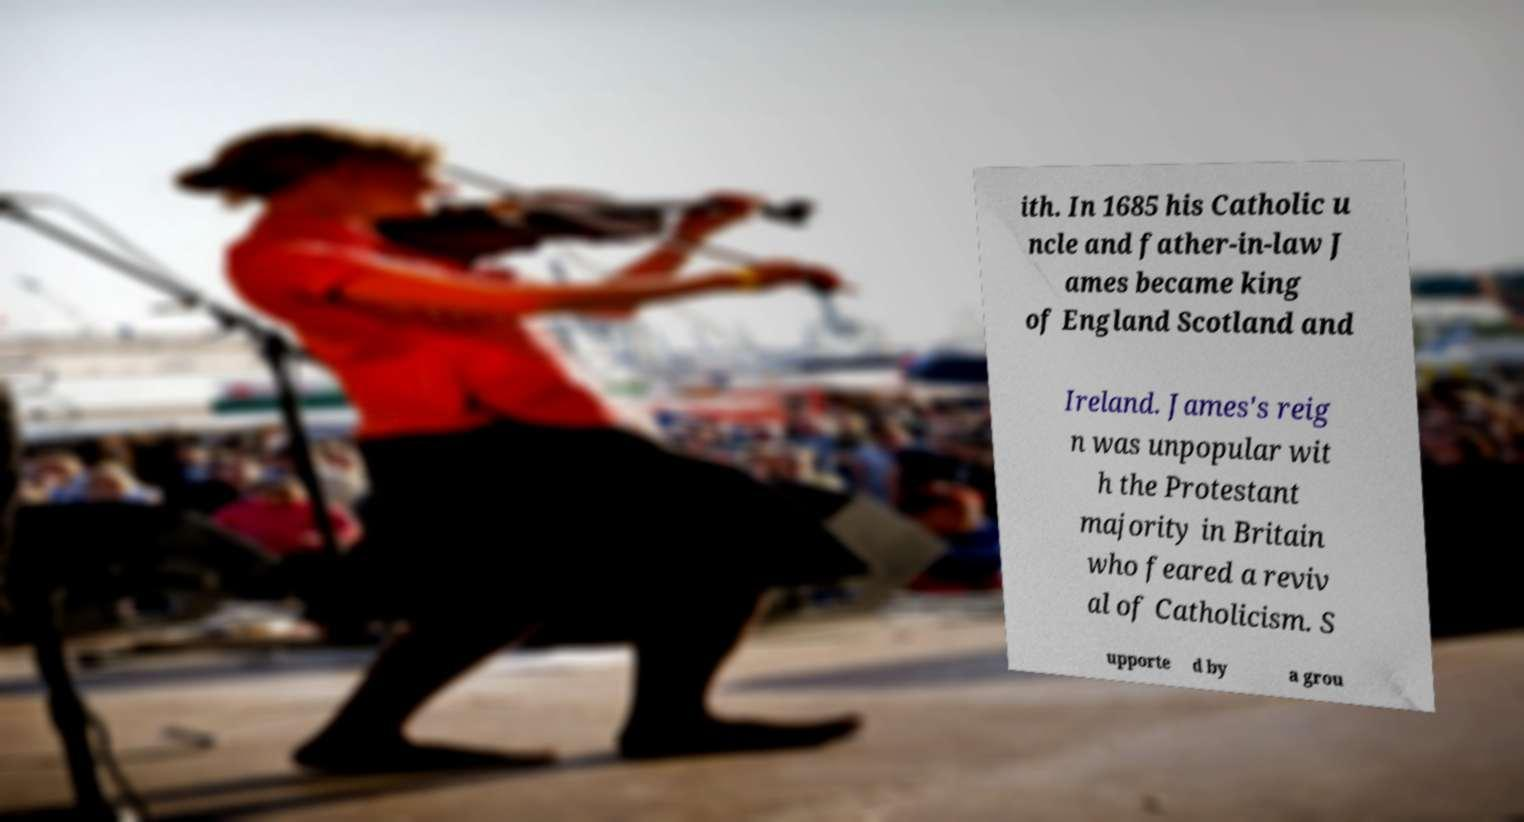Could you assist in decoding the text presented in this image and type it out clearly? ith. In 1685 his Catholic u ncle and father-in-law J ames became king of England Scotland and Ireland. James's reig n was unpopular wit h the Protestant majority in Britain who feared a reviv al of Catholicism. S upporte d by a grou 